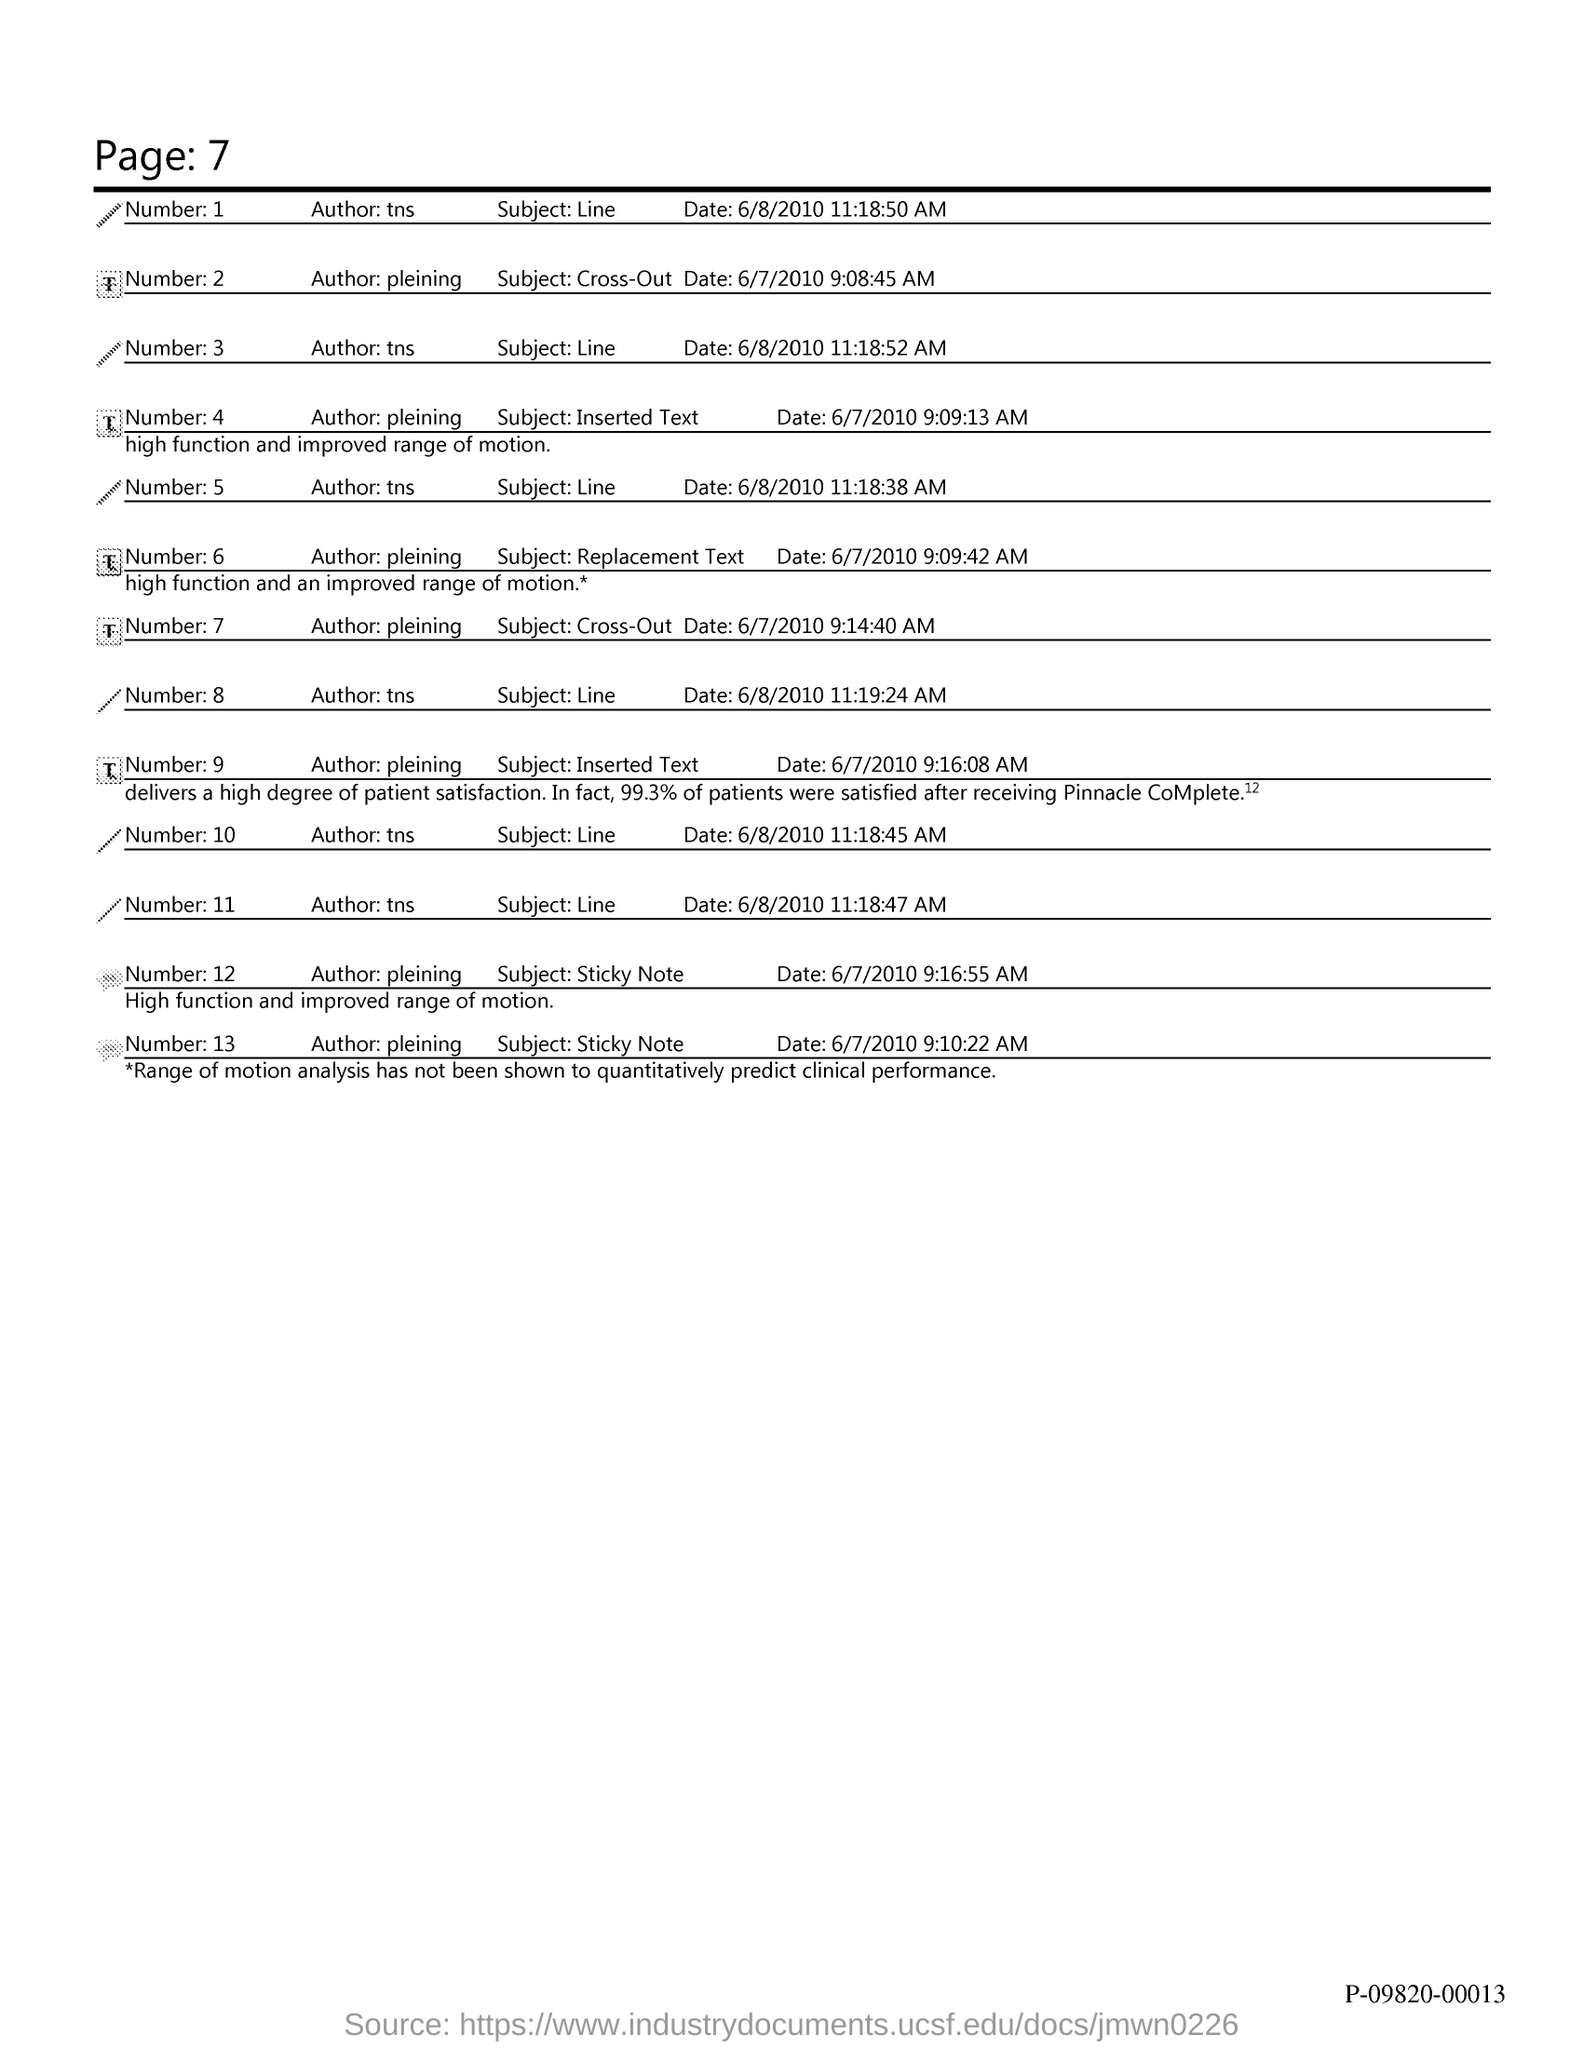What is the page no. at top of the page?
Keep it short and to the point. 7. 